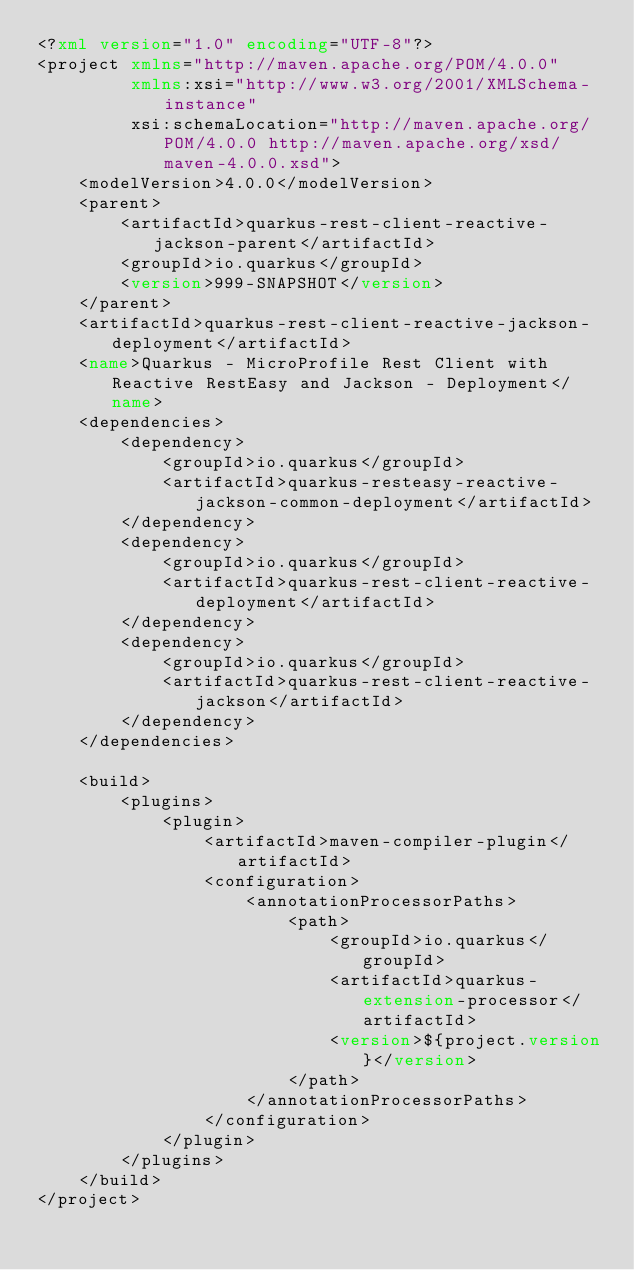Convert code to text. <code><loc_0><loc_0><loc_500><loc_500><_XML_><?xml version="1.0" encoding="UTF-8"?>
<project xmlns="http://maven.apache.org/POM/4.0.0"
         xmlns:xsi="http://www.w3.org/2001/XMLSchema-instance"
         xsi:schemaLocation="http://maven.apache.org/POM/4.0.0 http://maven.apache.org/xsd/maven-4.0.0.xsd">
    <modelVersion>4.0.0</modelVersion>
    <parent>
        <artifactId>quarkus-rest-client-reactive-jackson-parent</artifactId>
        <groupId>io.quarkus</groupId>
        <version>999-SNAPSHOT</version>
    </parent>
    <artifactId>quarkus-rest-client-reactive-jackson-deployment</artifactId>
    <name>Quarkus - MicroProfile Rest Client with Reactive RestEasy and Jackson - Deployment</name>
    <dependencies>
        <dependency>
            <groupId>io.quarkus</groupId>
            <artifactId>quarkus-resteasy-reactive-jackson-common-deployment</artifactId>
        </dependency>
        <dependency>
            <groupId>io.quarkus</groupId>
            <artifactId>quarkus-rest-client-reactive-deployment</artifactId>
        </dependency>
        <dependency>
            <groupId>io.quarkus</groupId>
            <artifactId>quarkus-rest-client-reactive-jackson</artifactId>
        </dependency>
    </dependencies>

    <build>
        <plugins>
            <plugin>
                <artifactId>maven-compiler-plugin</artifactId>
                <configuration>
                    <annotationProcessorPaths>
                        <path>
                            <groupId>io.quarkus</groupId>
                            <artifactId>quarkus-extension-processor</artifactId>
                            <version>${project.version}</version>
                        </path>
                    </annotationProcessorPaths>
                </configuration>
            </plugin>
        </plugins>
    </build>
</project>
</code> 